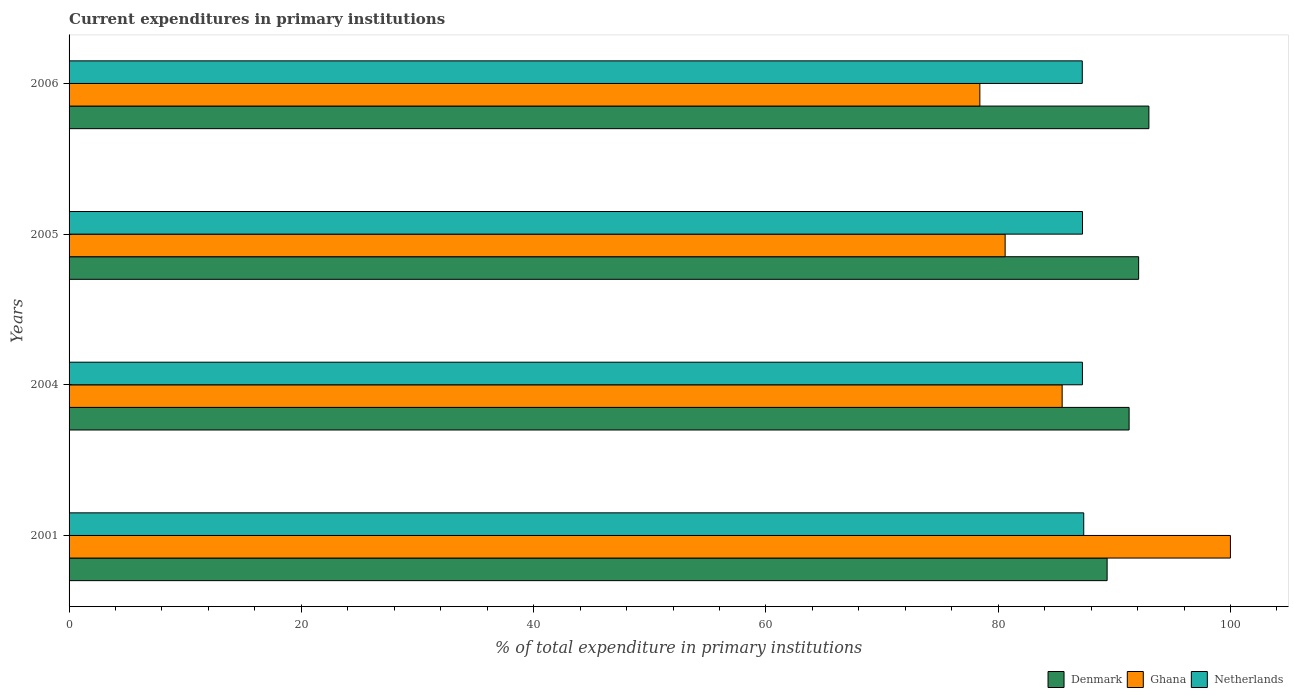How many different coloured bars are there?
Keep it short and to the point. 3. Are the number of bars per tick equal to the number of legend labels?
Give a very brief answer. Yes. Are the number of bars on each tick of the Y-axis equal?
Ensure brevity in your answer.  Yes. How many bars are there on the 3rd tick from the top?
Ensure brevity in your answer.  3. In how many cases, is the number of bars for a given year not equal to the number of legend labels?
Make the answer very short. 0. What is the current expenditures in primary institutions in Netherlands in 2001?
Your answer should be compact. 87.36. Across all years, what is the maximum current expenditures in primary institutions in Netherlands?
Give a very brief answer. 87.36. Across all years, what is the minimum current expenditures in primary institutions in Netherlands?
Offer a very short reply. 87.24. In which year was the current expenditures in primary institutions in Netherlands maximum?
Your answer should be compact. 2001. In which year was the current expenditures in primary institutions in Ghana minimum?
Your response must be concise. 2006. What is the total current expenditures in primary institutions in Denmark in the graph?
Your answer should be very brief. 365.71. What is the difference between the current expenditures in primary institutions in Netherlands in 2005 and that in 2006?
Ensure brevity in your answer.  0.02. What is the difference between the current expenditures in primary institutions in Netherlands in 2006 and the current expenditures in primary institutions in Denmark in 2005?
Offer a very short reply. -4.85. What is the average current expenditures in primary institutions in Netherlands per year?
Your answer should be compact. 87.28. In the year 2006, what is the difference between the current expenditures in primary institutions in Netherlands and current expenditures in primary institutions in Denmark?
Give a very brief answer. -5.73. What is the ratio of the current expenditures in primary institutions in Ghana in 2004 to that in 2006?
Make the answer very short. 1.09. Is the current expenditures in primary institutions in Netherlands in 2001 less than that in 2006?
Offer a terse response. No. What is the difference between the highest and the second highest current expenditures in primary institutions in Netherlands?
Provide a succinct answer. 0.1. What is the difference between the highest and the lowest current expenditures in primary institutions in Netherlands?
Your response must be concise. 0.12. What does the 3rd bar from the top in 2001 represents?
Provide a short and direct response. Denmark. What does the 3rd bar from the bottom in 2001 represents?
Provide a succinct answer. Netherlands. Is it the case that in every year, the sum of the current expenditures in primary institutions in Denmark and current expenditures in primary institutions in Netherlands is greater than the current expenditures in primary institutions in Ghana?
Keep it short and to the point. Yes. Are all the bars in the graph horizontal?
Give a very brief answer. Yes. What is the difference between two consecutive major ticks on the X-axis?
Provide a succinct answer. 20. Does the graph contain any zero values?
Ensure brevity in your answer.  No. What is the title of the graph?
Offer a very short reply. Current expenditures in primary institutions. Does "Cuba" appear as one of the legend labels in the graph?
Provide a short and direct response. No. What is the label or title of the X-axis?
Your response must be concise. % of total expenditure in primary institutions. What is the % of total expenditure in primary institutions in Denmark in 2001?
Your response must be concise. 89.38. What is the % of total expenditure in primary institutions of Ghana in 2001?
Give a very brief answer. 99.99. What is the % of total expenditure in primary institutions in Netherlands in 2001?
Provide a succinct answer. 87.36. What is the % of total expenditure in primary institutions of Denmark in 2004?
Your answer should be compact. 91.27. What is the % of total expenditure in primary institutions of Ghana in 2004?
Provide a succinct answer. 85.51. What is the % of total expenditure in primary institutions of Netherlands in 2004?
Your response must be concise. 87.25. What is the % of total expenditure in primary institutions in Denmark in 2005?
Your response must be concise. 92.09. What is the % of total expenditure in primary institutions in Ghana in 2005?
Offer a terse response. 80.6. What is the % of total expenditure in primary institutions of Netherlands in 2005?
Your answer should be compact. 87.26. What is the % of total expenditure in primary institutions in Denmark in 2006?
Provide a succinct answer. 92.97. What is the % of total expenditure in primary institutions in Ghana in 2006?
Offer a terse response. 78.42. What is the % of total expenditure in primary institutions of Netherlands in 2006?
Provide a short and direct response. 87.24. Across all years, what is the maximum % of total expenditure in primary institutions of Denmark?
Provide a succinct answer. 92.97. Across all years, what is the maximum % of total expenditure in primary institutions of Ghana?
Your answer should be compact. 99.99. Across all years, what is the maximum % of total expenditure in primary institutions in Netherlands?
Your answer should be compact. 87.36. Across all years, what is the minimum % of total expenditure in primary institutions of Denmark?
Give a very brief answer. 89.38. Across all years, what is the minimum % of total expenditure in primary institutions of Ghana?
Offer a very short reply. 78.42. Across all years, what is the minimum % of total expenditure in primary institutions of Netherlands?
Your answer should be very brief. 87.24. What is the total % of total expenditure in primary institutions of Denmark in the graph?
Make the answer very short. 365.71. What is the total % of total expenditure in primary institutions of Ghana in the graph?
Your answer should be very brief. 344.52. What is the total % of total expenditure in primary institutions in Netherlands in the graph?
Ensure brevity in your answer.  349.11. What is the difference between the % of total expenditure in primary institutions in Denmark in 2001 and that in 2004?
Provide a succinct answer. -1.89. What is the difference between the % of total expenditure in primary institutions of Ghana in 2001 and that in 2004?
Your response must be concise. 14.49. What is the difference between the % of total expenditure in primary institutions in Netherlands in 2001 and that in 2004?
Your response must be concise. 0.11. What is the difference between the % of total expenditure in primary institutions in Denmark in 2001 and that in 2005?
Your response must be concise. -2.71. What is the difference between the % of total expenditure in primary institutions in Ghana in 2001 and that in 2005?
Your answer should be very brief. 19.4. What is the difference between the % of total expenditure in primary institutions of Netherlands in 2001 and that in 2005?
Keep it short and to the point. 0.1. What is the difference between the % of total expenditure in primary institutions in Denmark in 2001 and that in 2006?
Keep it short and to the point. -3.6. What is the difference between the % of total expenditure in primary institutions in Ghana in 2001 and that in 2006?
Your answer should be very brief. 21.57. What is the difference between the % of total expenditure in primary institutions of Netherlands in 2001 and that in 2006?
Ensure brevity in your answer.  0.12. What is the difference between the % of total expenditure in primary institutions of Denmark in 2004 and that in 2005?
Keep it short and to the point. -0.82. What is the difference between the % of total expenditure in primary institutions of Ghana in 2004 and that in 2005?
Your answer should be very brief. 4.91. What is the difference between the % of total expenditure in primary institutions of Netherlands in 2004 and that in 2005?
Your answer should be compact. -0.01. What is the difference between the % of total expenditure in primary institutions in Denmark in 2004 and that in 2006?
Provide a succinct answer. -1.7. What is the difference between the % of total expenditure in primary institutions of Ghana in 2004 and that in 2006?
Keep it short and to the point. 7.09. What is the difference between the % of total expenditure in primary institutions in Netherlands in 2004 and that in 2006?
Give a very brief answer. 0.01. What is the difference between the % of total expenditure in primary institutions in Denmark in 2005 and that in 2006?
Keep it short and to the point. -0.88. What is the difference between the % of total expenditure in primary institutions of Ghana in 2005 and that in 2006?
Your response must be concise. 2.18. What is the difference between the % of total expenditure in primary institutions in Netherlands in 2005 and that in 2006?
Make the answer very short. 0.02. What is the difference between the % of total expenditure in primary institutions in Denmark in 2001 and the % of total expenditure in primary institutions in Ghana in 2004?
Your answer should be compact. 3.87. What is the difference between the % of total expenditure in primary institutions in Denmark in 2001 and the % of total expenditure in primary institutions in Netherlands in 2004?
Offer a very short reply. 2.13. What is the difference between the % of total expenditure in primary institutions in Ghana in 2001 and the % of total expenditure in primary institutions in Netherlands in 2004?
Provide a short and direct response. 12.74. What is the difference between the % of total expenditure in primary institutions of Denmark in 2001 and the % of total expenditure in primary institutions of Ghana in 2005?
Make the answer very short. 8.78. What is the difference between the % of total expenditure in primary institutions of Denmark in 2001 and the % of total expenditure in primary institutions of Netherlands in 2005?
Offer a very short reply. 2.12. What is the difference between the % of total expenditure in primary institutions of Ghana in 2001 and the % of total expenditure in primary institutions of Netherlands in 2005?
Your response must be concise. 12.73. What is the difference between the % of total expenditure in primary institutions in Denmark in 2001 and the % of total expenditure in primary institutions in Ghana in 2006?
Provide a short and direct response. 10.96. What is the difference between the % of total expenditure in primary institutions in Denmark in 2001 and the % of total expenditure in primary institutions in Netherlands in 2006?
Provide a succinct answer. 2.14. What is the difference between the % of total expenditure in primary institutions of Ghana in 2001 and the % of total expenditure in primary institutions of Netherlands in 2006?
Provide a short and direct response. 12.75. What is the difference between the % of total expenditure in primary institutions of Denmark in 2004 and the % of total expenditure in primary institutions of Ghana in 2005?
Provide a short and direct response. 10.67. What is the difference between the % of total expenditure in primary institutions in Denmark in 2004 and the % of total expenditure in primary institutions in Netherlands in 2005?
Make the answer very short. 4.01. What is the difference between the % of total expenditure in primary institutions in Ghana in 2004 and the % of total expenditure in primary institutions in Netherlands in 2005?
Your answer should be very brief. -1.75. What is the difference between the % of total expenditure in primary institutions in Denmark in 2004 and the % of total expenditure in primary institutions in Ghana in 2006?
Provide a succinct answer. 12.85. What is the difference between the % of total expenditure in primary institutions in Denmark in 2004 and the % of total expenditure in primary institutions in Netherlands in 2006?
Make the answer very short. 4.03. What is the difference between the % of total expenditure in primary institutions in Ghana in 2004 and the % of total expenditure in primary institutions in Netherlands in 2006?
Ensure brevity in your answer.  -1.73. What is the difference between the % of total expenditure in primary institutions of Denmark in 2005 and the % of total expenditure in primary institutions of Ghana in 2006?
Keep it short and to the point. 13.67. What is the difference between the % of total expenditure in primary institutions of Denmark in 2005 and the % of total expenditure in primary institutions of Netherlands in 2006?
Provide a succinct answer. 4.85. What is the difference between the % of total expenditure in primary institutions of Ghana in 2005 and the % of total expenditure in primary institutions of Netherlands in 2006?
Your answer should be very brief. -6.64. What is the average % of total expenditure in primary institutions in Denmark per year?
Your answer should be compact. 91.43. What is the average % of total expenditure in primary institutions in Ghana per year?
Keep it short and to the point. 86.13. What is the average % of total expenditure in primary institutions in Netherlands per year?
Give a very brief answer. 87.28. In the year 2001, what is the difference between the % of total expenditure in primary institutions in Denmark and % of total expenditure in primary institutions in Ghana?
Make the answer very short. -10.62. In the year 2001, what is the difference between the % of total expenditure in primary institutions in Denmark and % of total expenditure in primary institutions in Netherlands?
Provide a short and direct response. 2.01. In the year 2001, what is the difference between the % of total expenditure in primary institutions of Ghana and % of total expenditure in primary institutions of Netherlands?
Your response must be concise. 12.63. In the year 2004, what is the difference between the % of total expenditure in primary institutions in Denmark and % of total expenditure in primary institutions in Ghana?
Your answer should be compact. 5.76. In the year 2004, what is the difference between the % of total expenditure in primary institutions in Denmark and % of total expenditure in primary institutions in Netherlands?
Provide a succinct answer. 4.02. In the year 2004, what is the difference between the % of total expenditure in primary institutions of Ghana and % of total expenditure in primary institutions of Netherlands?
Your response must be concise. -1.74. In the year 2005, what is the difference between the % of total expenditure in primary institutions of Denmark and % of total expenditure in primary institutions of Ghana?
Your answer should be very brief. 11.49. In the year 2005, what is the difference between the % of total expenditure in primary institutions in Denmark and % of total expenditure in primary institutions in Netherlands?
Offer a terse response. 4.83. In the year 2005, what is the difference between the % of total expenditure in primary institutions in Ghana and % of total expenditure in primary institutions in Netherlands?
Provide a short and direct response. -6.66. In the year 2006, what is the difference between the % of total expenditure in primary institutions in Denmark and % of total expenditure in primary institutions in Ghana?
Offer a terse response. 14.55. In the year 2006, what is the difference between the % of total expenditure in primary institutions of Denmark and % of total expenditure in primary institutions of Netherlands?
Offer a terse response. 5.73. In the year 2006, what is the difference between the % of total expenditure in primary institutions of Ghana and % of total expenditure in primary institutions of Netherlands?
Your response must be concise. -8.82. What is the ratio of the % of total expenditure in primary institutions of Denmark in 2001 to that in 2004?
Your answer should be very brief. 0.98. What is the ratio of the % of total expenditure in primary institutions in Ghana in 2001 to that in 2004?
Ensure brevity in your answer.  1.17. What is the ratio of the % of total expenditure in primary institutions of Netherlands in 2001 to that in 2004?
Provide a succinct answer. 1. What is the ratio of the % of total expenditure in primary institutions of Denmark in 2001 to that in 2005?
Your answer should be compact. 0.97. What is the ratio of the % of total expenditure in primary institutions of Ghana in 2001 to that in 2005?
Ensure brevity in your answer.  1.24. What is the ratio of the % of total expenditure in primary institutions in Netherlands in 2001 to that in 2005?
Make the answer very short. 1. What is the ratio of the % of total expenditure in primary institutions in Denmark in 2001 to that in 2006?
Make the answer very short. 0.96. What is the ratio of the % of total expenditure in primary institutions of Ghana in 2001 to that in 2006?
Provide a short and direct response. 1.28. What is the ratio of the % of total expenditure in primary institutions of Netherlands in 2001 to that in 2006?
Ensure brevity in your answer.  1. What is the ratio of the % of total expenditure in primary institutions of Ghana in 2004 to that in 2005?
Your answer should be compact. 1.06. What is the ratio of the % of total expenditure in primary institutions of Denmark in 2004 to that in 2006?
Offer a very short reply. 0.98. What is the ratio of the % of total expenditure in primary institutions of Ghana in 2004 to that in 2006?
Your answer should be compact. 1.09. What is the ratio of the % of total expenditure in primary institutions of Netherlands in 2004 to that in 2006?
Give a very brief answer. 1. What is the ratio of the % of total expenditure in primary institutions of Ghana in 2005 to that in 2006?
Your answer should be compact. 1.03. What is the difference between the highest and the second highest % of total expenditure in primary institutions in Denmark?
Provide a succinct answer. 0.88. What is the difference between the highest and the second highest % of total expenditure in primary institutions in Ghana?
Ensure brevity in your answer.  14.49. What is the difference between the highest and the second highest % of total expenditure in primary institutions of Netherlands?
Keep it short and to the point. 0.1. What is the difference between the highest and the lowest % of total expenditure in primary institutions in Denmark?
Provide a short and direct response. 3.6. What is the difference between the highest and the lowest % of total expenditure in primary institutions in Ghana?
Offer a very short reply. 21.57. What is the difference between the highest and the lowest % of total expenditure in primary institutions of Netherlands?
Provide a succinct answer. 0.12. 